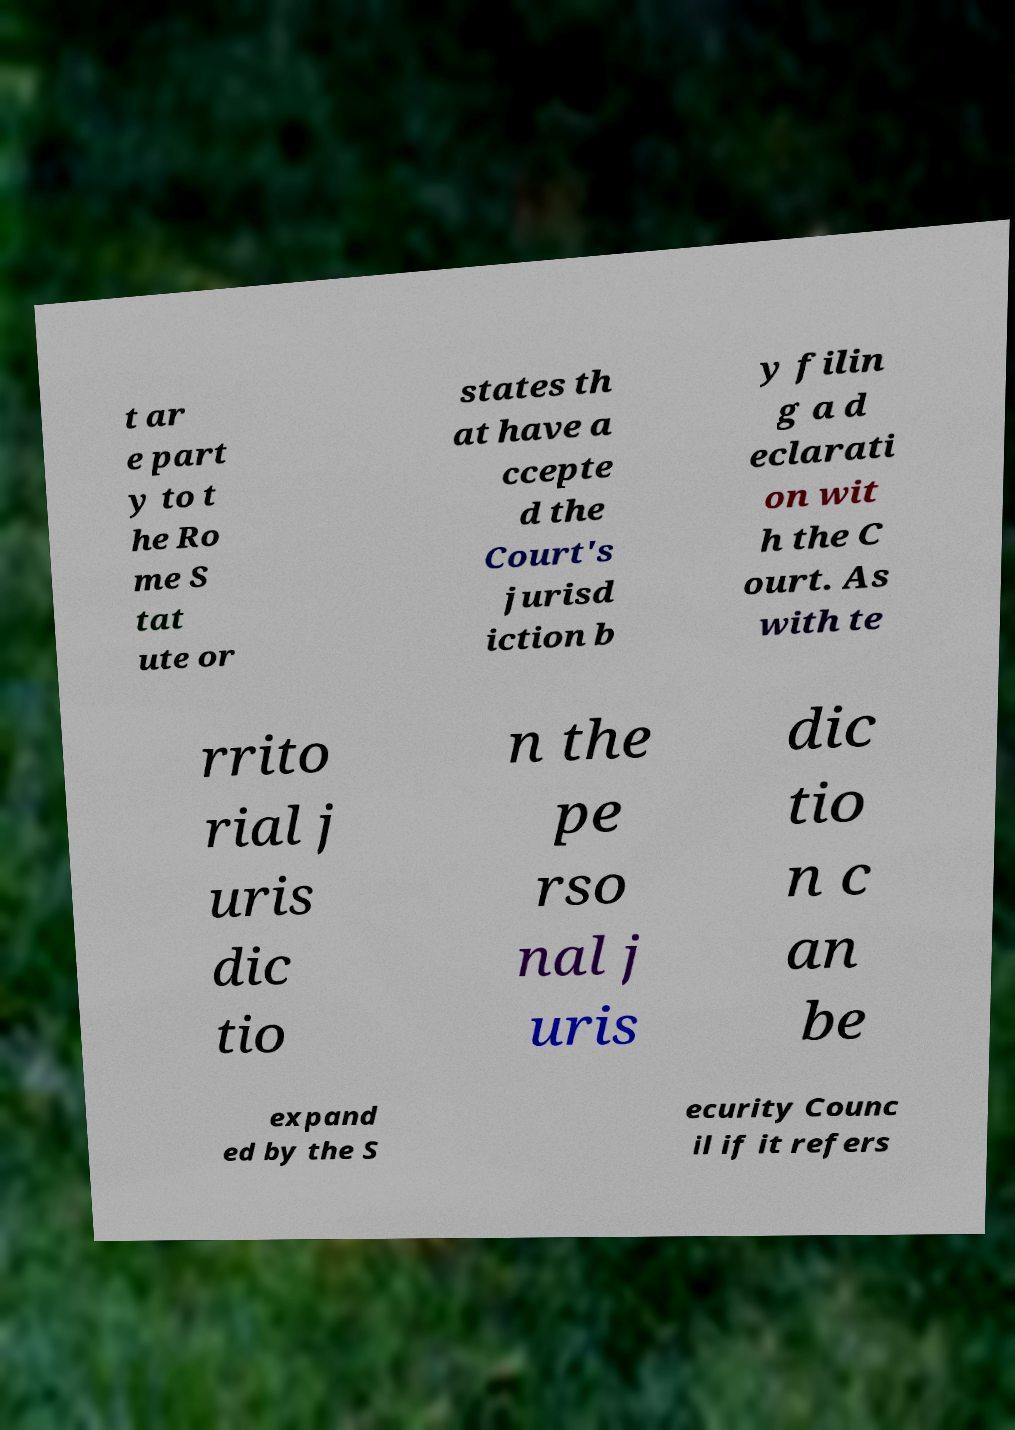What messages or text are displayed in this image? I need them in a readable, typed format. t ar e part y to t he Ro me S tat ute or states th at have a ccepte d the Court's jurisd iction b y filin g a d eclarati on wit h the C ourt. As with te rrito rial j uris dic tio n the pe rso nal j uris dic tio n c an be expand ed by the S ecurity Counc il if it refers 